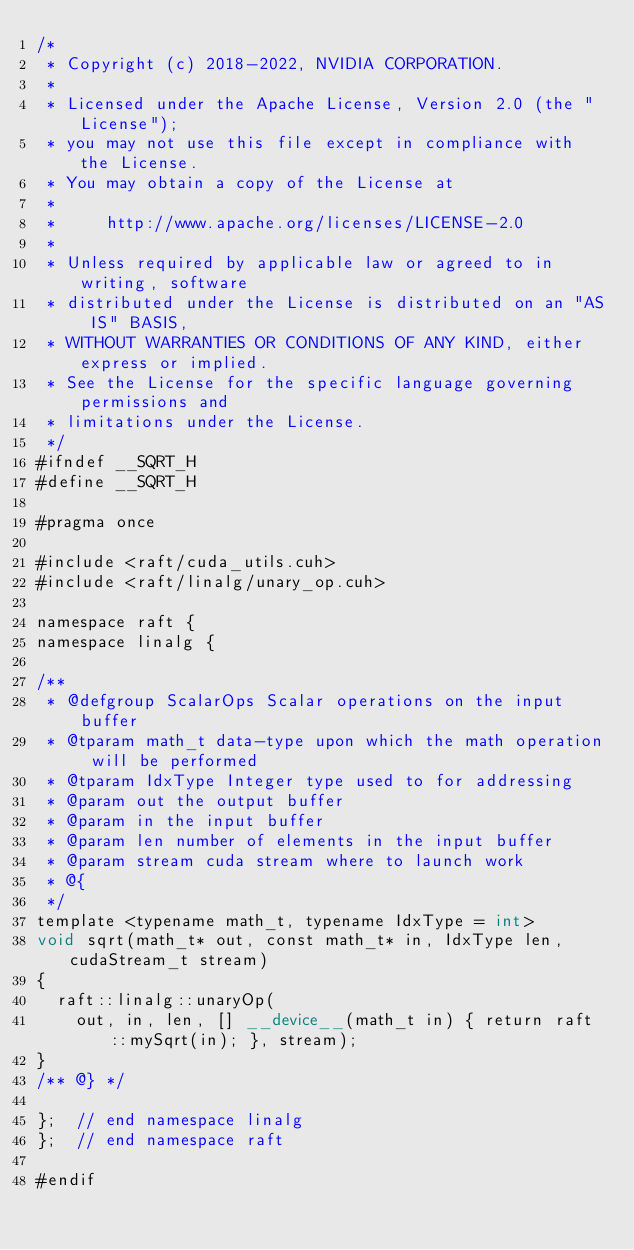Convert code to text. <code><loc_0><loc_0><loc_500><loc_500><_Cuda_>/*
 * Copyright (c) 2018-2022, NVIDIA CORPORATION.
 *
 * Licensed under the Apache License, Version 2.0 (the "License");
 * you may not use this file except in compliance with the License.
 * You may obtain a copy of the License at
 *
 *     http://www.apache.org/licenses/LICENSE-2.0
 *
 * Unless required by applicable law or agreed to in writing, software
 * distributed under the License is distributed on an "AS IS" BASIS,
 * WITHOUT WARRANTIES OR CONDITIONS OF ANY KIND, either express or implied.
 * See the License for the specific language governing permissions and
 * limitations under the License.
 */
#ifndef __SQRT_H
#define __SQRT_H

#pragma once

#include <raft/cuda_utils.cuh>
#include <raft/linalg/unary_op.cuh>

namespace raft {
namespace linalg {

/**
 * @defgroup ScalarOps Scalar operations on the input buffer
 * @tparam math_t data-type upon which the math operation will be performed
 * @tparam IdxType Integer type used to for addressing
 * @param out the output buffer
 * @param in the input buffer
 * @param len number of elements in the input buffer
 * @param stream cuda stream where to launch work
 * @{
 */
template <typename math_t, typename IdxType = int>
void sqrt(math_t* out, const math_t* in, IdxType len, cudaStream_t stream)
{
  raft::linalg::unaryOp(
    out, in, len, [] __device__(math_t in) { return raft::mySqrt(in); }, stream);
}
/** @} */

};  // end namespace linalg
};  // end namespace raft

#endif</code> 